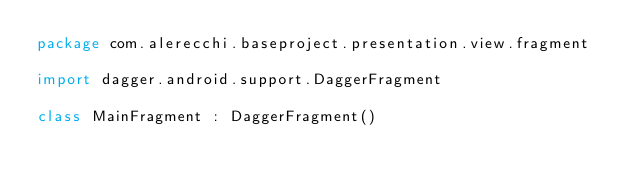Convert code to text. <code><loc_0><loc_0><loc_500><loc_500><_Kotlin_>package com.alerecchi.baseproject.presentation.view.fragment

import dagger.android.support.DaggerFragment

class MainFragment : DaggerFragment()</code> 